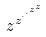<formula> <loc_0><loc_0><loc_500><loc_500>z ^ { z ^ { \cdot ^ { \cdot ^ { z ^ { z } } } } }</formula> 